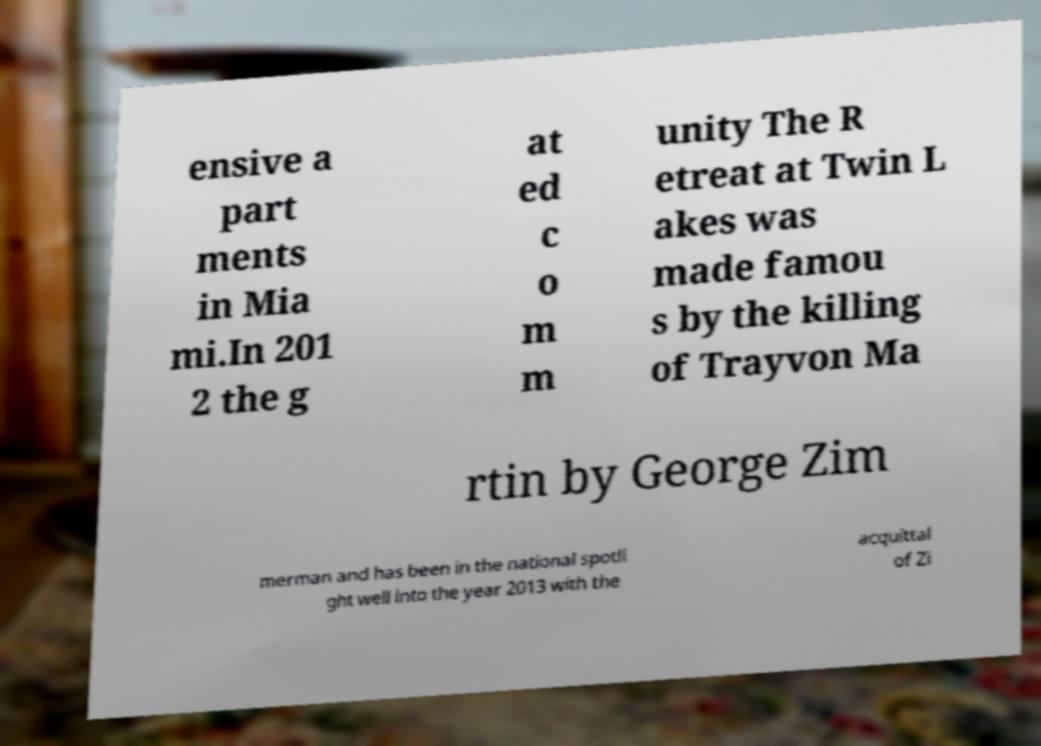There's text embedded in this image that I need extracted. Can you transcribe it verbatim? ensive a part ments in Mia mi.In 201 2 the g at ed c o m m unity The R etreat at Twin L akes was made famou s by the killing of Trayvon Ma rtin by George Zim merman and has been in the national spotli ght well into the year 2013 with the acquittal of Zi 